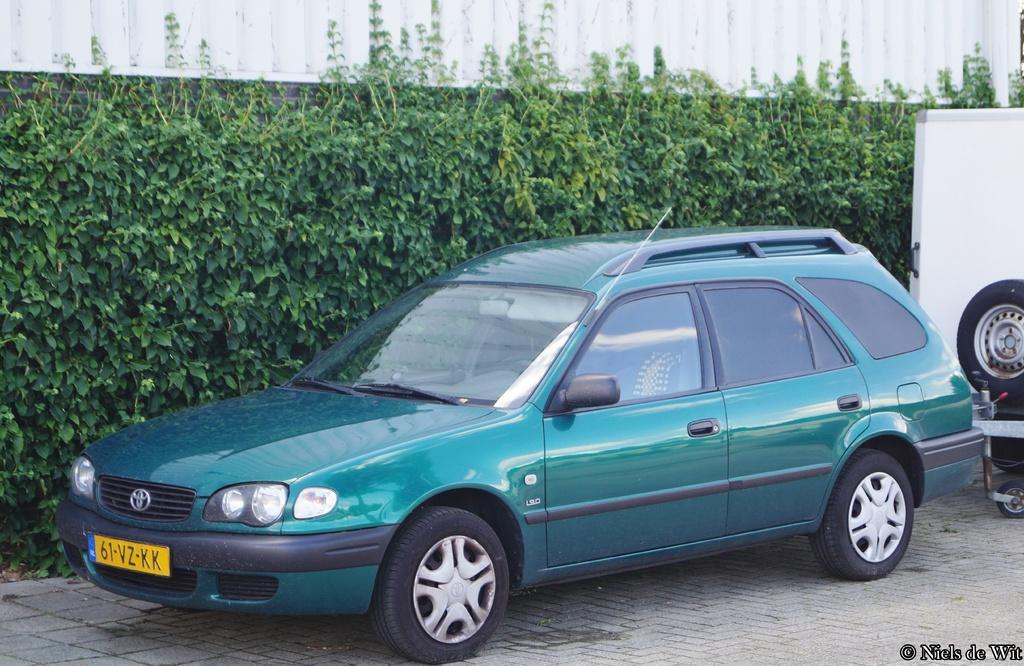Describe this image in one or two sentences. In this image I can see a car which is green and black in color on the road and another vehicle which is white in color behind it. In the background I can see few trees and the white colored surface. 